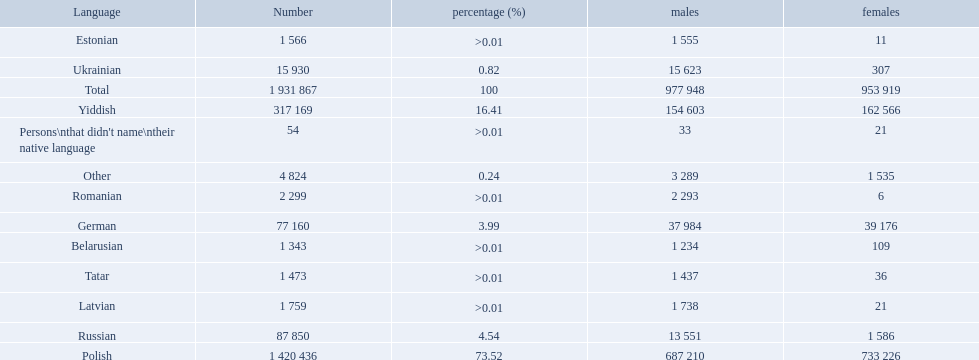What are all the languages? Polish, Yiddish, Russian, German, Ukrainian, Romanian, Latvian, Estonian, Tatar, Belarusian, Other. Which only have percentages >0.01? Romanian, Latvian, Estonian, Tatar, Belarusian. Of these, which has the greatest number of speakers? Romanian. What named native languages spoken in the warsaw governorate have more males then females? Russian, Ukrainian, Romanian, Latvian, Estonian, Tatar, Belarusian. Which of those have less then 500 males listed? Romanian, Latvian, Estonian, Tatar, Belarusian. Of the remaining languages which of them have less then 20 females? Romanian, Estonian. Which of these has the highest total number listed? Romanian. 